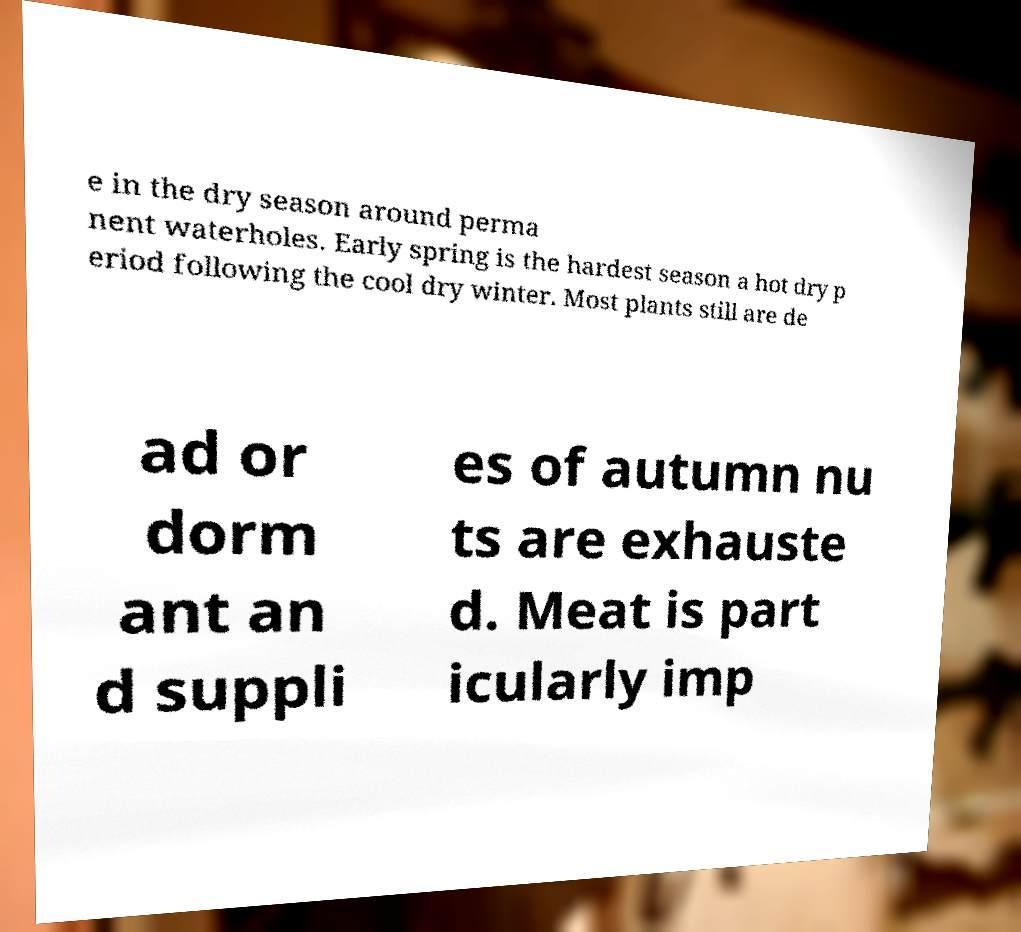Please read and relay the text visible in this image. What does it say? e in the dry season around perma nent waterholes. Early spring is the hardest season a hot dry p eriod following the cool dry winter. Most plants still are de ad or dorm ant an d suppli es of autumn nu ts are exhauste d. Meat is part icularly imp 